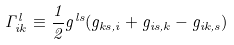Convert formula to latex. <formula><loc_0><loc_0><loc_500><loc_500>\Gamma _ { i k } ^ { l } \equiv \frac { 1 } { 2 } g ^ { l s } ( g _ { k s , i } + g _ { i s , k } - g _ { i k , s } )</formula> 